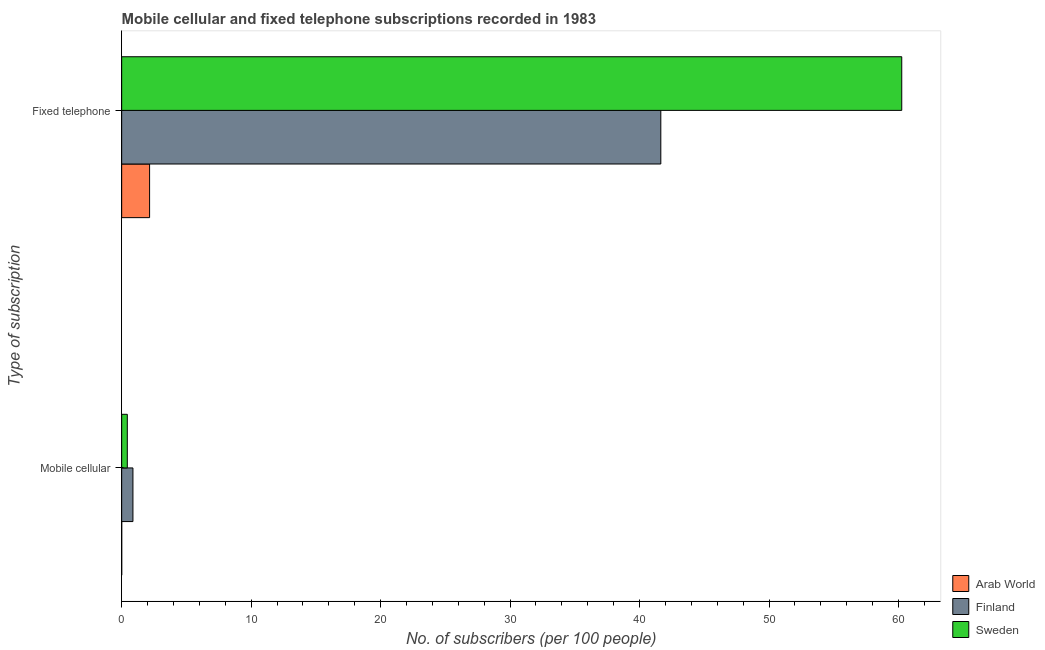How many different coloured bars are there?
Provide a succinct answer. 3. How many groups of bars are there?
Your answer should be very brief. 2. Are the number of bars per tick equal to the number of legend labels?
Your answer should be compact. Yes. How many bars are there on the 1st tick from the top?
Your answer should be compact. 3. What is the label of the 1st group of bars from the top?
Your response must be concise. Fixed telephone. What is the number of fixed telephone subscribers in Arab World?
Keep it short and to the point. 2.16. Across all countries, what is the maximum number of mobile cellular subscribers?
Keep it short and to the point. 0.87. Across all countries, what is the minimum number of fixed telephone subscribers?
Your answer should be very brief. 2.16. In which country was the number of fixed telephone subscribers minimum?
Offer a terse response. Arab World. What is the total number of fixed telephone subscribers in the graph?
Your answer should be compact. 104.05. What is the difference between the number of mobile cellular subscribers in Arab World and that in Sweden?
Provide a succinct answer. -0.43. What is the difference between the number of mobile cellular subscribers in Sweden and the number of fixed telephone subscribers in Finland?
Your answer should be compact. -41.21. What is the average number of fixed telephone subscribers per country?
Keep it short and to the point. 34.68. What is the difference between the number of mobile cellular subscribers and number of fixed telephone subscribers in Finland?
Offer a terse response. -40.77. What is the ratio of the number of mobile cellular subscribers in Sweden to that in Arab World?
Ensure brevity in your answer.  214.46. Is the number of fixed telephone subscribers in Finland less than that in Arab World?
Make the answer very short. No. In how many countries, is the number of mobile cellular subscribers greater than the average number of mobile cellular subscribers taken over all countries?
Keep it short and to the point. 1. What does the 2nd bar from the bottom in Fixed telephone represents?
Your answer should be very brief. Finland. How many bars are there?
Offer a very short reply. 6. How many countries are there in the graph?
Ensure brevity in your answer.  3. What is the difference between two consecutive major ticks on the X-axis?
Ensure brevity in your answer.  10. Does the graph contain any zero values?
Offer a terse response. No. Does the graph contain grids?
Provide a succinct answer. No. How many legend labels are there?
Offer a terse response. 3. What is the title of the graph?
Offer a terse response. Mobile cellular and fixed telephone subscriptions recorded in 1983. Does "Tajikistan" appear as one of the legend labels in the graph?
Provide a short and direct response. No. What is the label or title of the X-axis?
Your answer should be compact. No. of subscribers (per 100 people). What is the label or title of the Y-axis?
Offer a very short reply. Type of subscription. What is the No. of subscribers (per 100 people) of Arab World in Mobile cellular?
Offer a terse response. 0. What is the No. of subscribers (per 100 people) of Finland in Mobile cellular?
Offer a very short reply. 0.87. What is the No. of subscribers (per 100 people) in Sweden in Mobile cellular?
Offer a terse response. 0.44. What is the No. of subscribers (per 100 people) of Arab World in Fixed telephone?
Offer a terse response. 2.16. What is the No. of subscribers (per 100 people) in Finland in Fixed telephone?
Make the answer very short. 41.64. What is the No. of subscribers (per 100 people) in Sweden in Fixed telephone?
Offer a terse response. 60.25. Across all Type of subscription, what is the maximum No. of subscribers (per 100 people) of Arab World?
Your response must be concise. 2.16. Across all Type of subscription, what is the maximum No. of subscribers (per 100 people) in Finland?
Ensure brevity in your answer.  41.64. Across all Type of subscription, what is the maximum No. of subscribers (per 100 people) in Sweden?
Give a very brief answer. 60.25. Across all Type of subscription, what is the minimum No. of subscribers (per 100 people) in Arab World?
Give a very brief answer. 0. Across all Type of subscription, what is the minimum No. of subscribers (per 100 people) of Finland?
Give a very brief answer. 0.87. Across all Type of subscription, what is the minimum No. of subscribers (per 100 people) of Sweden?
Ensure brevity in your answer.  0.44. What is the total No. of subscribers (per 100 people) in Arab World in the graph?
Offer a very short reply. 2.16. What is the total No. of subscribers (per 100 people) in Finland in the graph?
Offer a terse response. 42.51. What is the total No. of subscribers (per 100 people) in Sweden in the graph?
Give a very brief answer. 60.69. What is the difference between the No. of subscribers (per 100 people) in Arab World in Mobile cellular and that in Fixed telephone?
Give a very brief answer. -2.15. What is the difference between the No. of subscribers (per 100 people) of Finland in Mobile cellular and that in Fixed telephone?
Offer a very short reply. -40.77. What is the difference between the No. of subscribers (per 100 people) of Sweden in Mobile cellular and that in Fixed telephone?
Offer a very short reply. -59.82. What is the difference between the No. of subscribers (per 100 people) of Arab World in Mobile cellular and the No. of subscribers (per 100 people) of Finland in Fixed telephone?
Your answer should be very brief. -41.64. What is the difference between the No. of subscribers (per 100 people) in Arab World in Mobile cellular and the No. of subscribers (per 100 people) in Sweden in Fixed telephone?
Offer a terse response. -60.25. What is the difference between the No. of subscribers (per 100 people) of Finland in Mobile cellular and the No. of subscribers (per 100 people) of Sweden in Fixed telephone?
Offer a very short reply. -59.38. What is the average No. of subscribers (per 100 people) in Arab World per Type of subscription?
Make the answer very short. 1.08. What is the average No. of subscribers (per 100 people) in Finland per Type of subscription?
Provide a succinct answer. 21.26. What is the average No. of subscribers (per 100 people) in Sweden per Type of subscription?
Offer a very short reply. 30.34. What is the difference between the No. of subscribers (per 100 people) of Arab World and No. of subscribers (per 100 people) of Finland in Mobile cellular?
Make the answer very short. -0.87. What is the difference between the No. of subscribers (per 100 people) of Arab World and No. of subscribers (per 100 people) of Sweden in Mobile cellular?
Offer a terse response. -0.43. What is the difference between the No. of subscribers (per 100 people) in Finland and No. of subscribers (per 100 people) in Sweden in Mobile cellular?
Offer a very short reply. 0.43. What is the difference between the No. of subscribers (per 100 people) of Arab World and No. of subscribers (per 100 people) of Finland in Fixed telephone?
Provide a succinct answer. -39.49. What is the difference between the No. of subscribers (per 100 people) in Arab World and No. of subscribers (per 100 people) in Sweden in Fixed telephone?
Provide a short and direct response. -58.1. What is the difference between the No. of subscribers (per 100 people) of Finland and No. of subscribers (per 100 people) of Sweden in Fixed telephone?
Ensure brevity in your answer.  -18.61. What is the ratio of the No. of subscribers (per 100 people) in Arab World in Mobile cellular to that in Fixed telephone?
Offer a terse response. 0. What is the ratio of the No. of subscribers (per 100 people) in Finland in Mobile cellular to that in Fixed telephone?
Offer a terse response. 0.02. What is the ratio of the No. of subscribers (per 100 people) of Sweden in Mobile cellular to that in Fixed telephone?
Offer a terse response. 0.01. What is the difference between the highest and the second highest No. of subscribers (per 100 people) in Arab World?
Ensure brevity in your answer.  2.15. What is the difference between the highest and the second highest No. of subscribers (per 100 people) of Finland?
Your answer should be compact. 40.77. What is the difference between the highest and the second highest No. of subscribers (per 100 people) in Sweden?
Provide a succinct answer. 59.82. What is the difference between the highest and the lowest No. of subscribers (per 100 people) in Arab World?
Provide a short and direct response. 2.15. What is the difference between the highest and the lowest No. of subscribers (per 100 people) in Finland?
Provide a short and direct response. 40.77. What is the difference between the highest and the lowest No. of subscribers (per 100 people) of Sweden?
Make the answer very short. 59.82. 